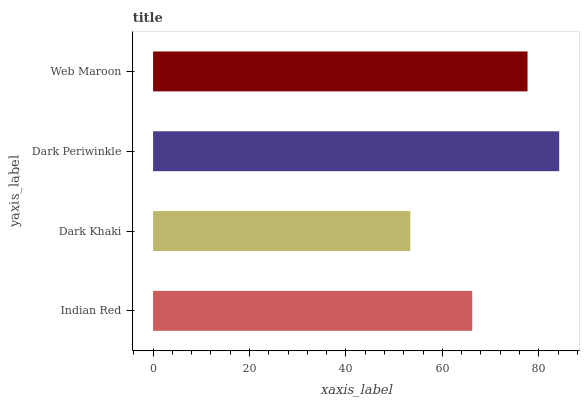Is Dark Khaki the minimum?
Answer yes or no. Yes. Is Dark Periwinkle the maximum?
Answer yes or no. Yes. Is Dark Periwinkle the minimum?
Answer yes or no. No. Is Dark Khaki the maximum?
Answer yes or no. No. Is Dark Periwinkle greater than Dark Khaki?
Answer yes or no. Yes. Is Dark Khaki less than Dark Periwinkle?
Answer yes or no. Yes. Is Dark Khaki greater than Dark Periwinkle?
Answer yes or no. No. Is Dark Periwinkle less than Dark Khaki?
Answer yes or no. No. Is Web Maroon the high median?
Answer yes or no. Yes. Is Indian Red the low median?
Answer yes or no. Yes. Is Dark Periwinkle the high median?
Answer yes or no. No. Is Web Maroon the low median?
Answer yes or no. No. 